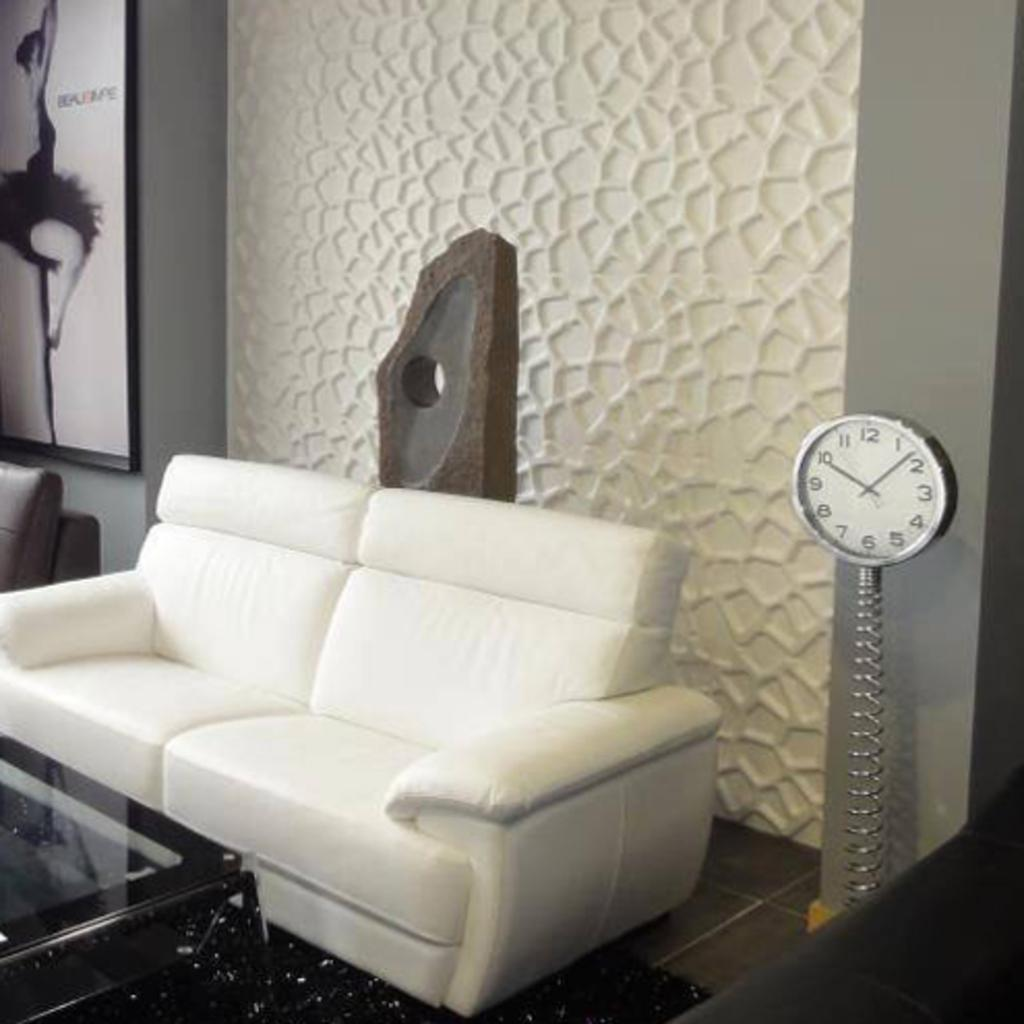<image>
Share a concise interpretation of the image provided. living room set that has a white couch and a clock that says 10:08. 